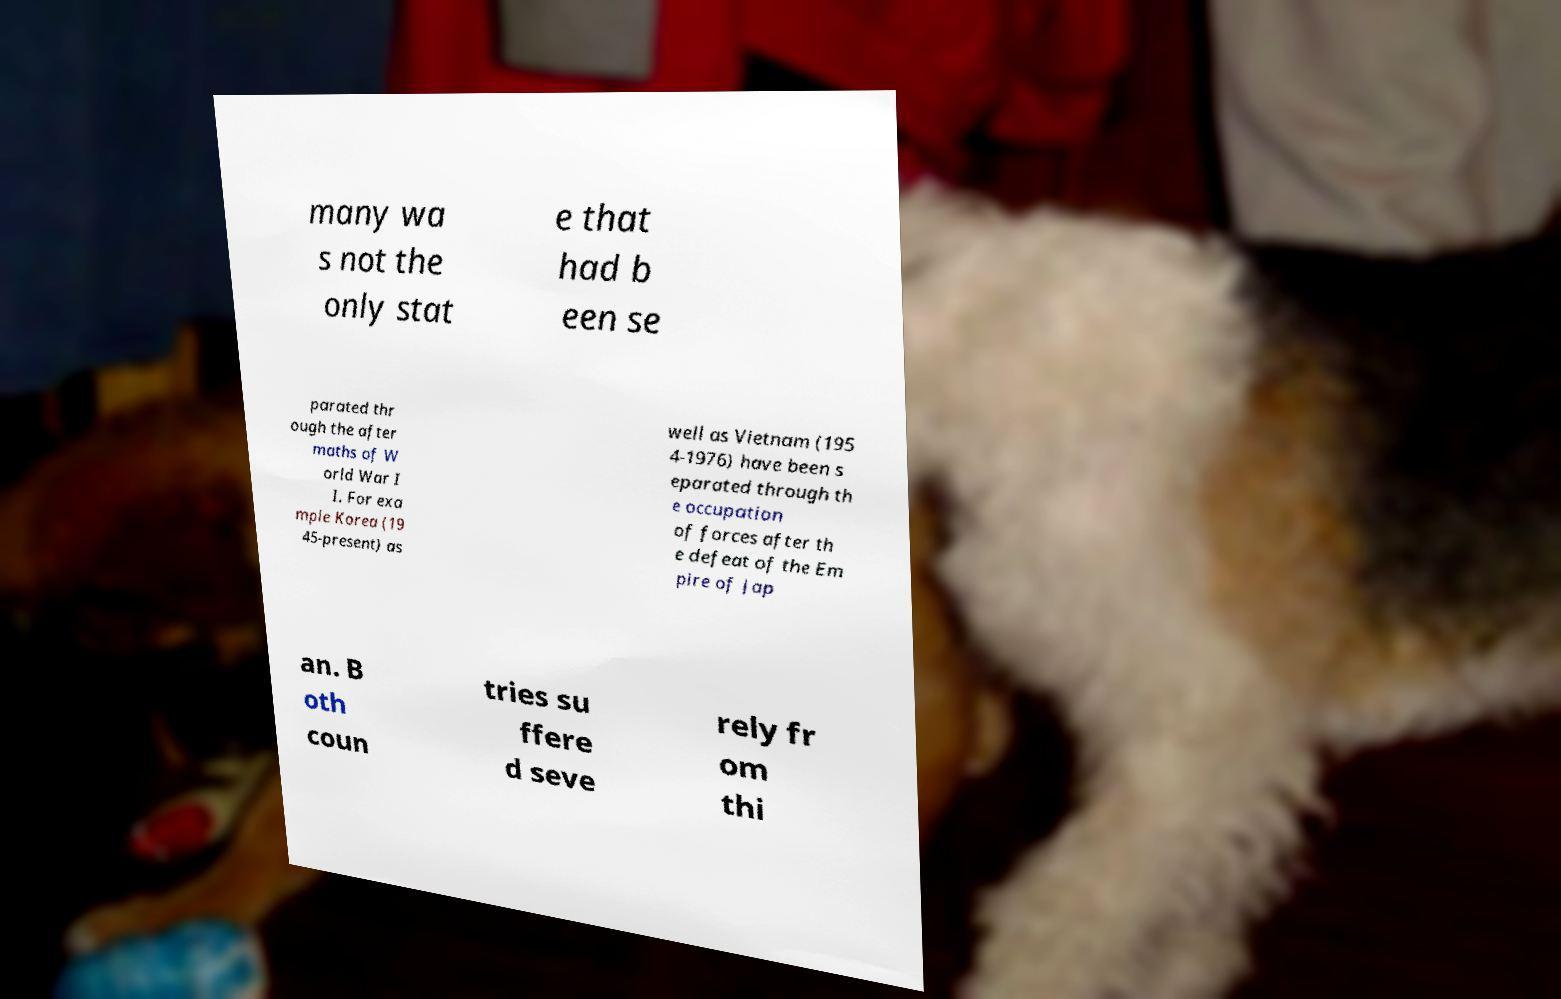I need the written content from this picture converted into text. Can you do that? many wa s not the only stat e that had b een se parated thr ough the after maths of W orld War I I. For exa mple Korea (19 45-present) as well as Vietnam (195 4-1976) have been s eparated through th e occupation of forces after th e defeat of the Em pire of Jap an. B oth coun tries su ffere d seve rely fr om thi 